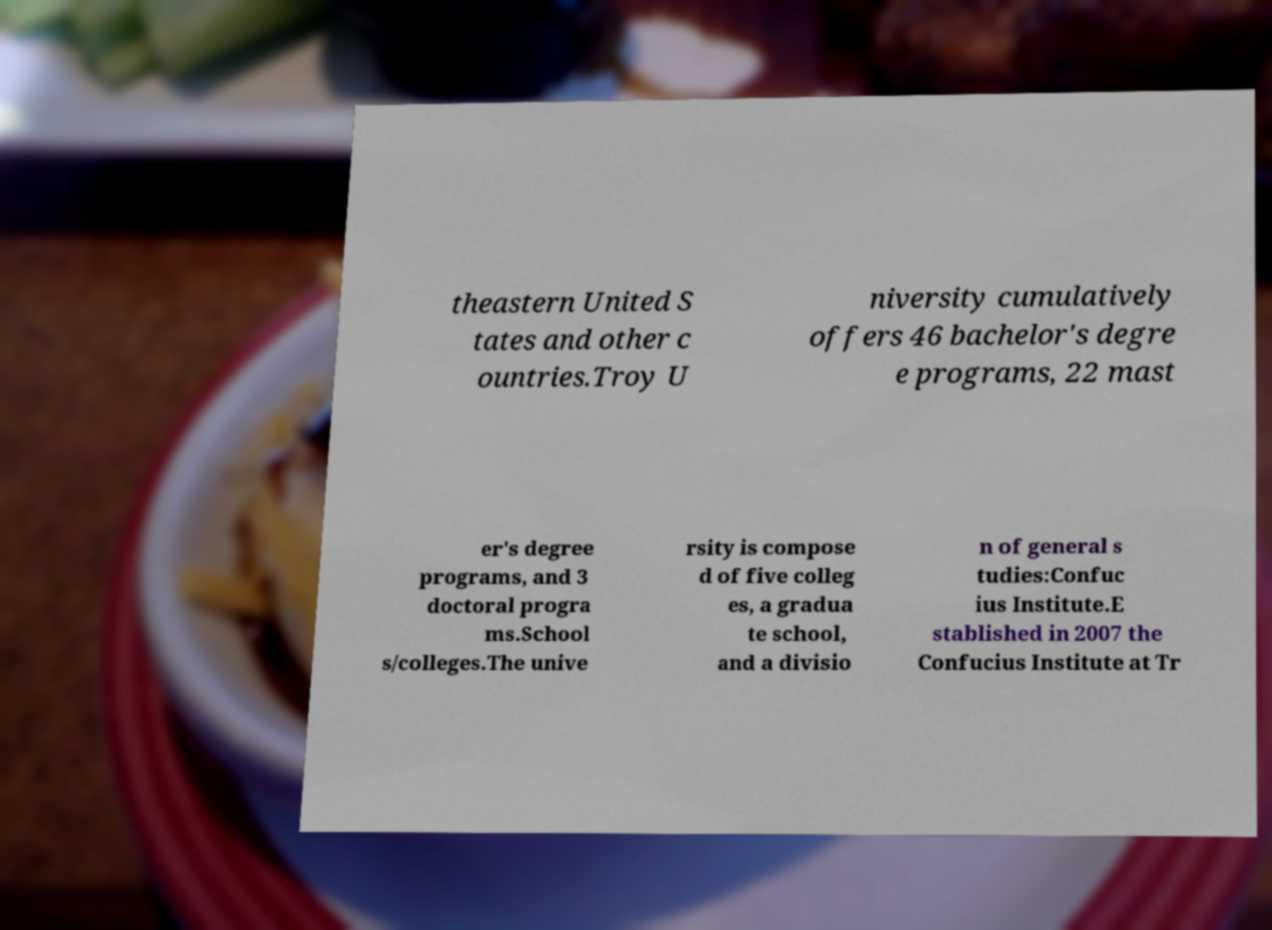Can you read and provide the text displayed in the image?This photo seems to have some interesting text. Can you extract and type it out for me? theastern United S tates and other c ountries.Troy U niversity cumulatively offers 46 bachelor's degre e programs, 22 mast er's degree programs, and 3 doctoral progra ms.School s/colleges.The unive rsity is compose d of five colleg es, a gradua te school, and a divisio n of general s tudies:Confuc ius Institute.E stablished in 2007 the Confucius Institute at Tr 